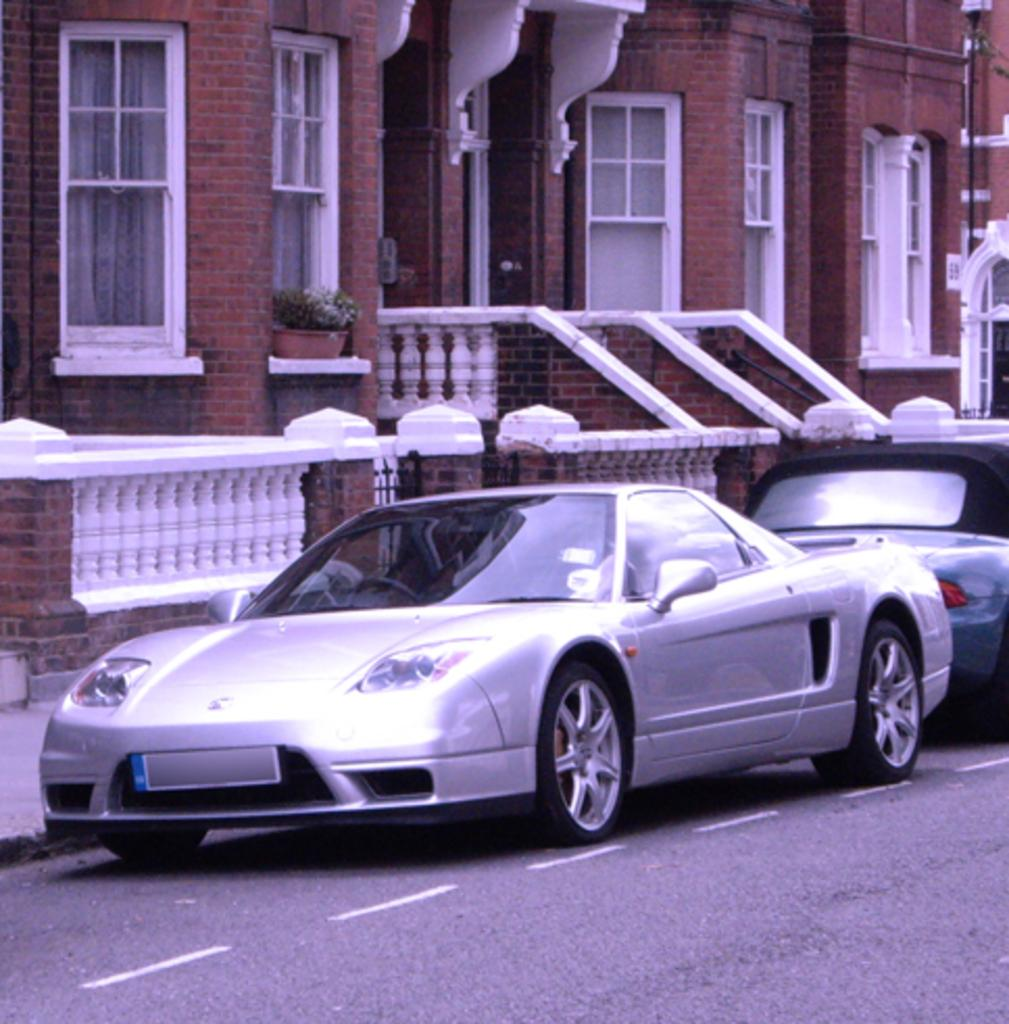How many vehicles can be seen on the road in the image? There are two vehicles on the road in the image. What can be seen in the background of the image? There is a building in the background of the image. What type of structure is present in the image? There is a fencing wall in the image. What type of class is being taught in the image? There is no class or teaching activity present in the image. What sound can be heard coming from the vehicles in the image? The image is static, so no sound can be heard from the vehicles. 